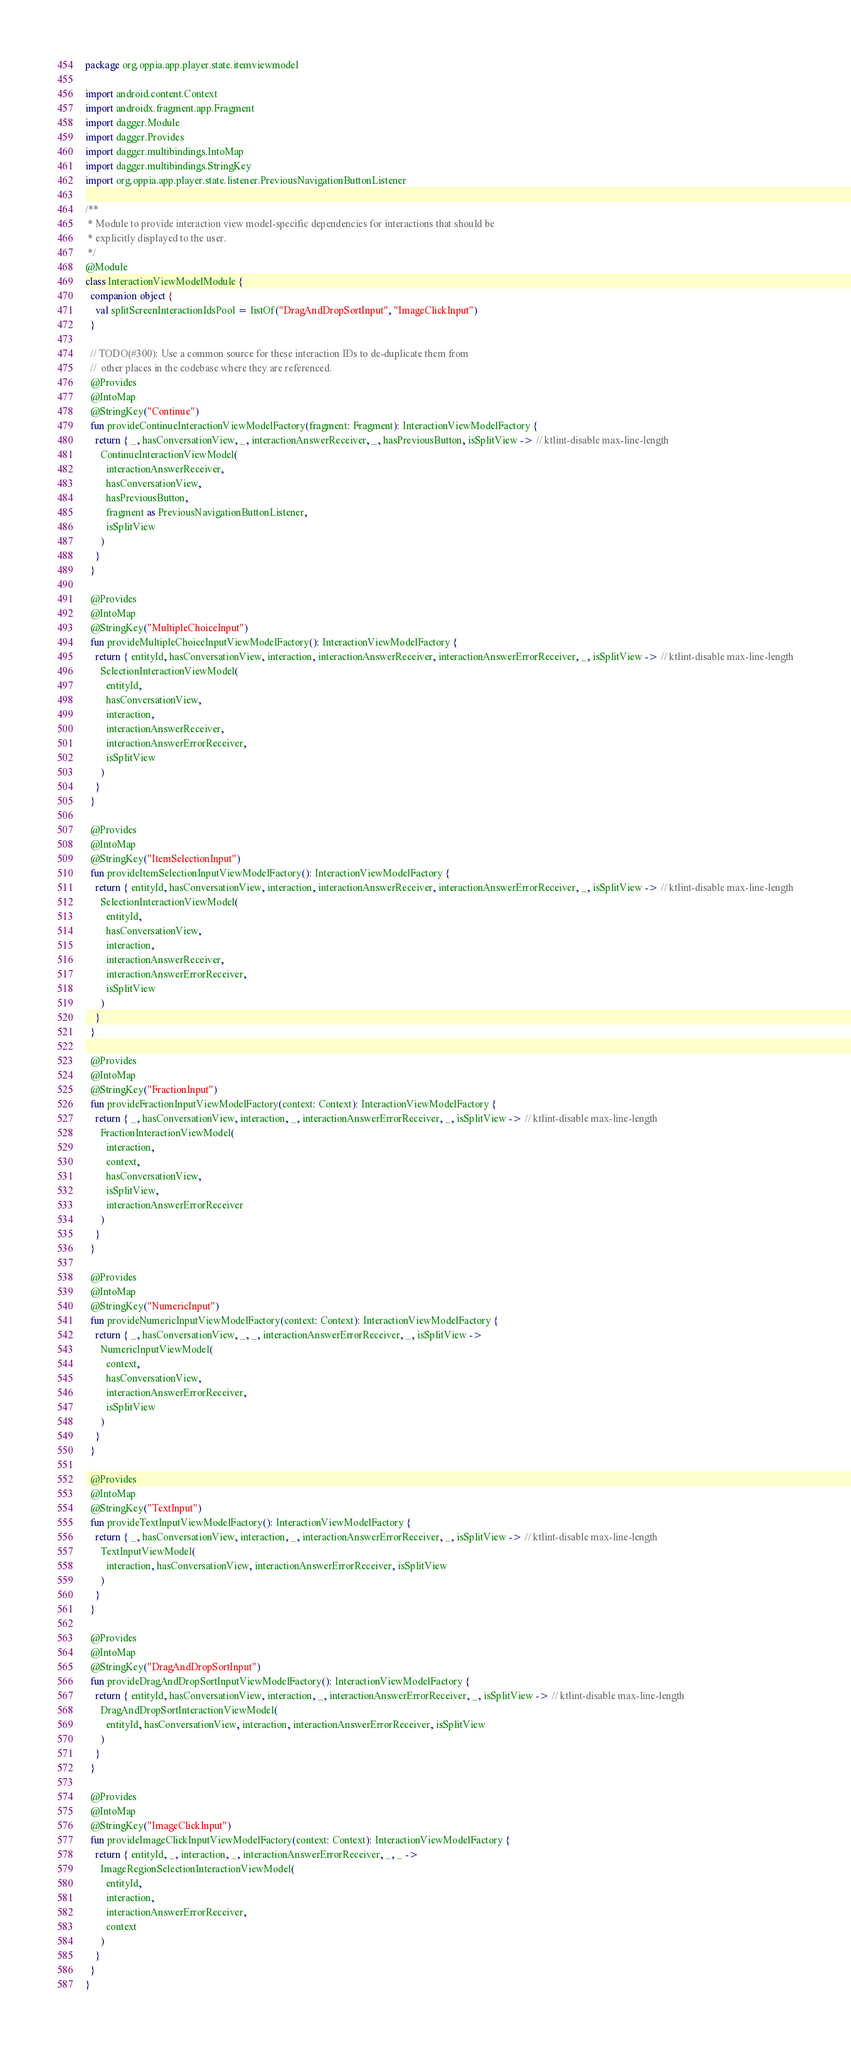<code> <loc_0><loc_0><loc_500><loc_500><_Kotlin_>package org.oppia.app.player.state.itemviewmodel

import android.content.Context
import androidx.fragment.app.Fragment
import dagger.Module
import dagger.Provides
import dagger.multibindings.IntoMap
import dagger.multibindings.StringKey
import org.oppia.app.player.state.listener.PreviousNavigationButtonListener

/**
 * Module to provide interaction view model-specific dependencies for interactions that should be
 * explicitly displayed to the user.
 */
@Module
class InteractionViewModelModule {
  companion object {
    val splitScreenInteractionIdsPool = listOf("DragAndDropSortInput", "ImageClickInput")
  }

  // TODO(#300): Use a common source for these interaction IDs to de-duplicate them from
  //  other places in the codebase where they are referenced.
  @Provides
  @IntoMap
  @StringKey("Continue")
  fun provideContinueInteractionViewModelFactory(fragment: Fragment): InteractionViewModelFactory {
    return { _, hasConversationView, _, interactionAnswerReceiver, _, hasPreviousButton, isSplitView -> // ktlint-disable max-line-length
      ContinueInteractionViewModel(
        interactionAnswerReceiver,
        hasConversationView,
        hasPreviousButton,
        fragment as PreviousNavigationButtonListener,
        isSplitView
      )
    }
  }

  @Provides
  @IntoMap
  @StringKey("MultipleChoiceInput")
  fun provideMultipleChoiceInputViewModelFactory(): InteractionViewModelFactory {
    return { entityId, hasConversationView, interaction, interactionAnswerReceiver, interactionAnswerErrorReceiver, _, isSplitView -> // ktlint-disable max-line-length
      SelectionInteractionViewModel(
        entityId,
        hasConversationView,
        interaction,
        interactionAnswerReceiver,
        interactionAnswerErrorReceiver,
        isSplitView
      )
    }
  }

  @Provides
  @IntoMap
  @StringKey("ItemSelectionInput")
  fun provideItemSelectionInputViewModelFactory(): InteractionViewModelFactory {
    return { entityId, hasConversationView, interaction, interactionAnswerReceiver, interactionAnswerErrorReceiver, _, isSplitView -> // ktlint-disable max-line-length
      SelectionInteractionViewModel(
        entityId,
        hasConversationView,
        interaction,
        interactionAnswerReceiver,
        interactionAnswerErrorReceiver,
        isSplitView
      )
    }
  }

  @Provides
  @IntoMap
  @StringKey("FractionInput")
  fun provideFractionInputViewModelFactory(context: Context): InteractionViewModelFactory {
    return { _, hasConversationView, interaction, _, interactionAnswerErrorReceiver, _, isSplitView -> // ktlint-disable max-line-length
      FractionInteractionViewModel(
        interaction,
        context,
        hasConversationView,
        isSplitView,
        interactionAnswerErrorReceiver
      )
    }
  }

  @Provides
  @IntoMap
  @StringKey("NumericInput")
  fun provideNumericInputViewModelFactory(context: Context): InteractionViewModelFactory {
    return { _, hasConversationView, _, _, interactionAnswerErrorReceiver, _, isSplitView ->
      NumericInputViewModel(
        context,
        hasConversationView,
        interactionAnswerErrorReceiver,
        isSplitView
      )
    }
  }

  @Provides
  @IntoMap
  @StringKey("TextInput")
  fun provideTextInputViewModelFactory(): InteractionViewModelFactory {
    return { _, hasConversationView, interaction, _, interactionAnswerErrorReceiver, _, isSplitView -> // ktlint-disable max-line-length
      TextInputViewModel(
        interaction, hasConversationView, interactionAnswerErrorReceiver, isSplitView
      )
    }
  }

  @Provides
  @IntoMap
  @StringKey("DragAndDropSortInput")
  fun provideDragAndDropSortInputViewModelFactory(): InteractionViewModelFactory {
    return { entityId, hasConversationView, interaction, _, interactionAnswerErrorReceiver, _, isSplitView -> // ktlint-disable max-line-length
      DragAndDropSortInteractionViewModel(
        entityId, hasConversationView, interaction, interactionAnswerErrorReceiver, isSplitView
      )
    }
  }

  @Provides
  @IntoMap
  @StringKey("ImageClickInput")
  fun provideImageClickInputViewModelFactory(context: Context): InteractionViewModelFactory {
    return { entityId, _, interaction, _, interactionAnswerErrorReceiver, _, _ ->
      ImageRegionSelectionInteractionViewModel(
        entityId,
        interaction,
        interactionAnswerErrorReceiver,
        context
      )
    }
  }
}
</code> 